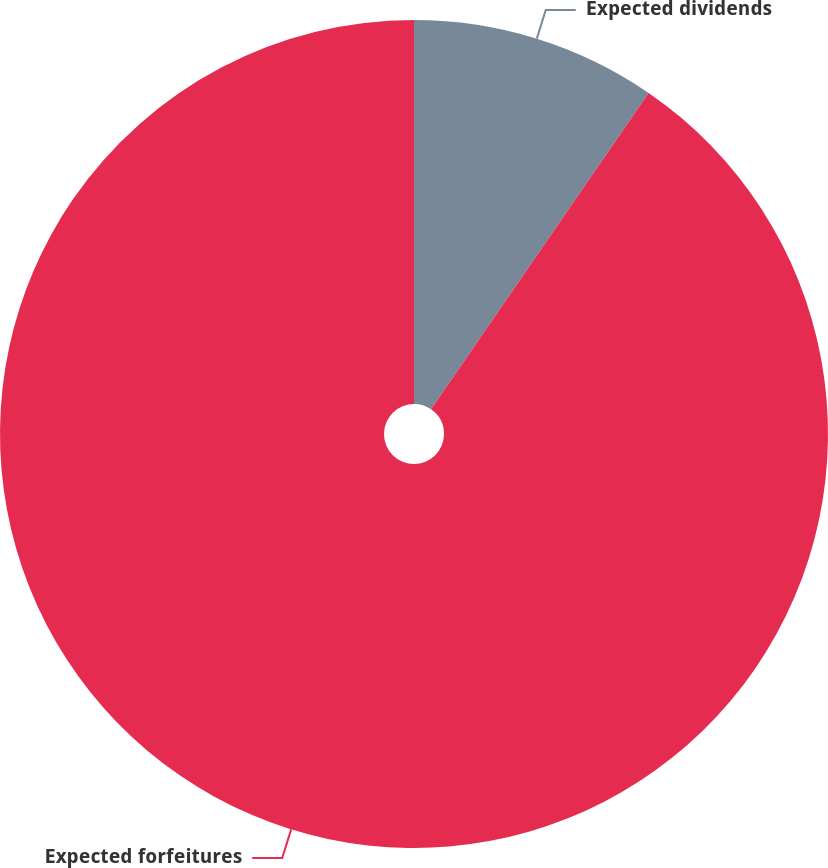<chart> <loc_0><loc_0><loc_500><loc_500><pie_chart><fcel>Expected dividends<fcel>Expected forfeitures<nl><fcel>9.59%<fcel>90.41%<nl></chart> 